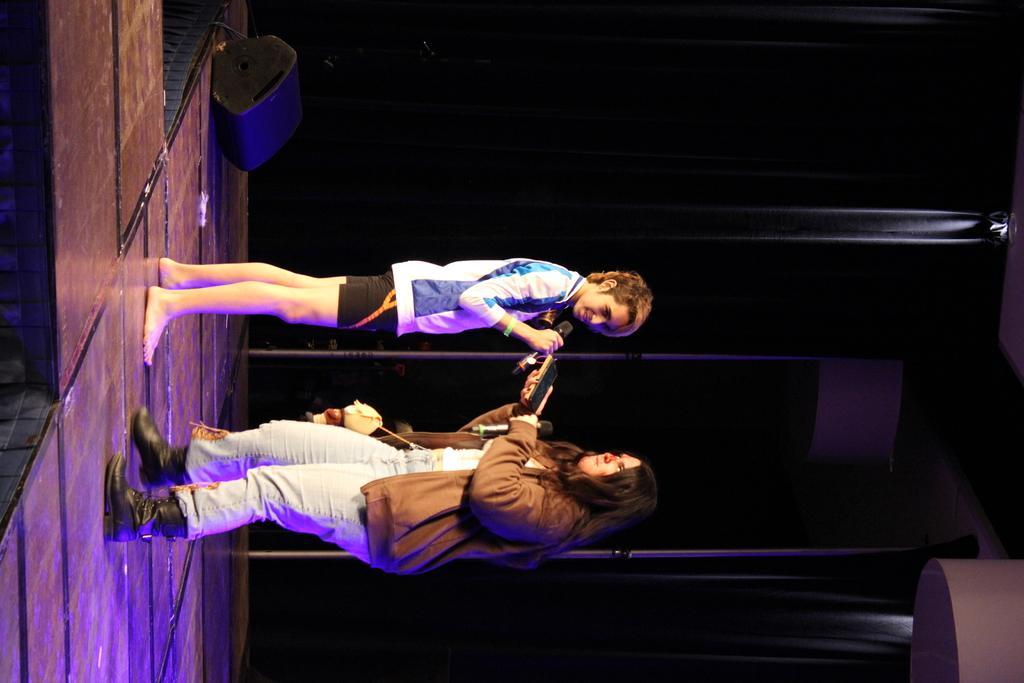Could you give a brief overview of what you see in this image? In this image I can see a woman wearing brown colored jacket, white pant and black shoe is standing on the stage and holding few objects in her hand and a person is standing and holding a microphone in his hand. I can see a speaker and in the background I can see the black colored curtain. 